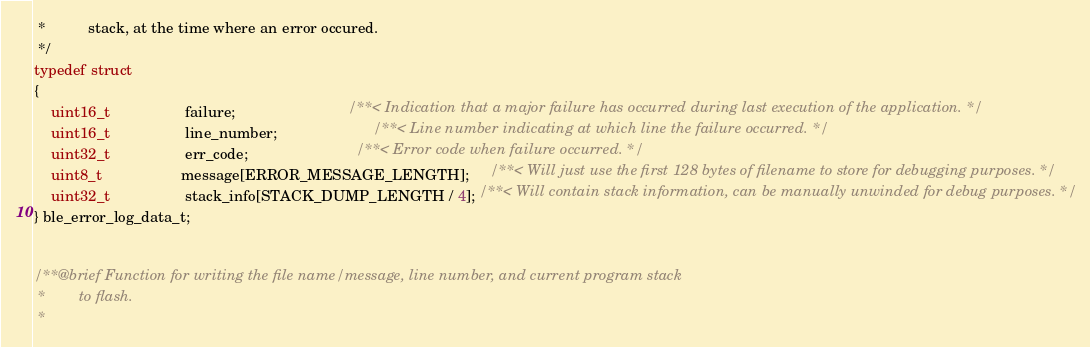<code> <loc_0><loc_0><loc_500><loc_500><_C_> *          stack, at the time where an error occured.
 */
typedef struct
{
    uint16_t                  failure;                           /**< Indication that a major failure has occurred during last execution of the application. */
    uint16_t                  line_number;                       /**< Line number indicating at which line the failure occurred. */
    uint32_t                  err_code;                          /**< Error code when failure occurred. */
    uint8_t                   message[ERROR_MESSAGE_LENGTH];     /**< Will just use the first 128 bytes of filename to store for debugging purposes. */
    uint32_t                  stack_info[STACK_DUMP_LENGTH / 4]; /**< Will contain stack information, can be manually unwinded for debug purposes. */
} ble_error_log_data_t;


/**@brief Function for writing the file name/message, line number, and current program stack
 *        to flash.
 * </code> 